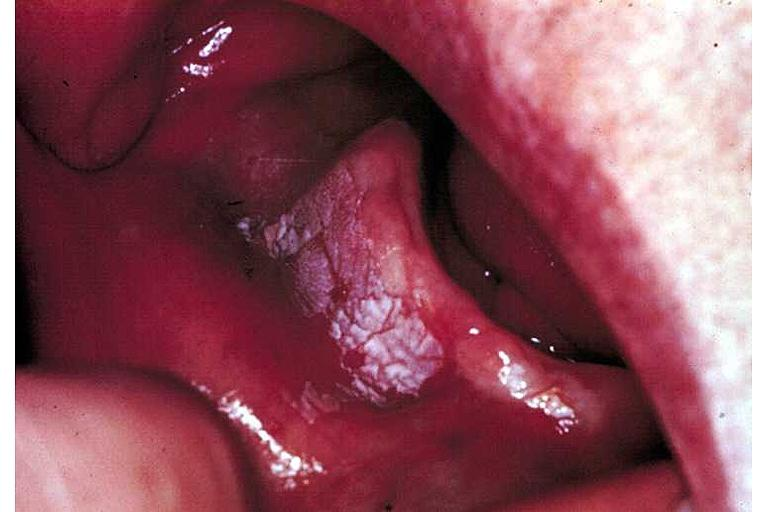what does this image show?
Answer the question using a single word or phrase. Leukoplakia 